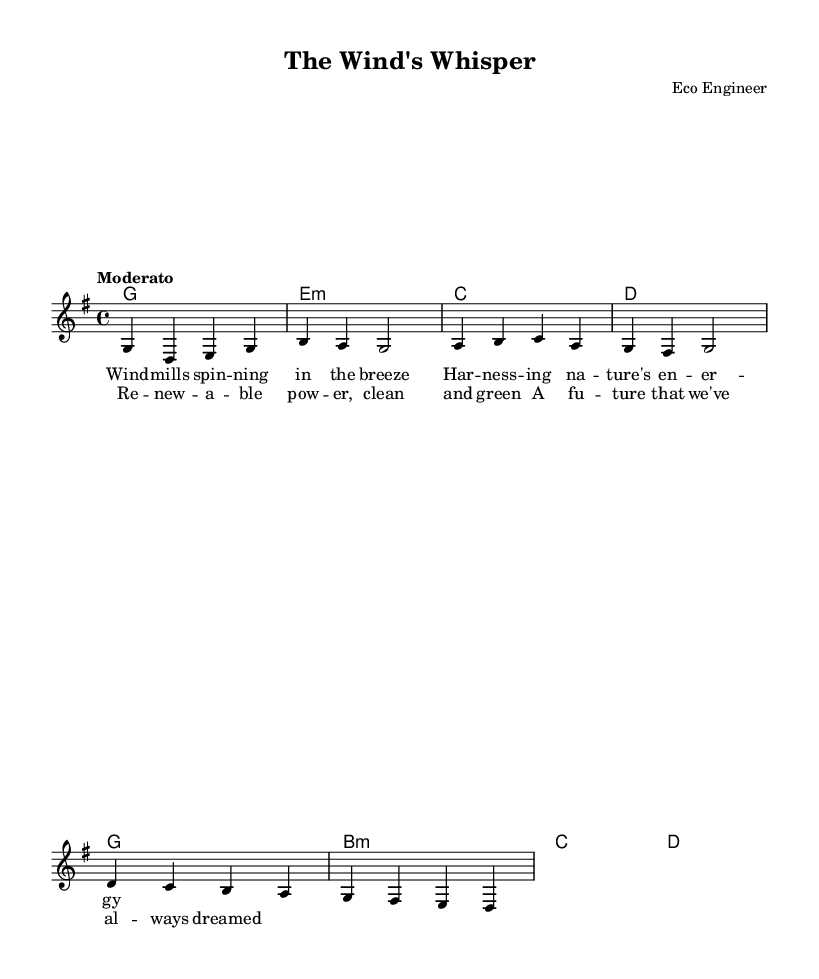What is the key signature of this music? The key signature is G major, which has one sharp (F#) indicated at the beginning of the staff.
Answer: G major What is the time signature of this music? The time signature is 4/4, which is shown at the beginning of the staff and indicates four beats per measure.
Answer: 4/4 What is the tempo marking for this piece? The tempo marking is "Moderato," indicating a moderate speed for the performance of the piece.
Answer: Moderato How many measures are in the melody section? The melody section consists of eight measures, which can be counted by looking at the notation and bar lines separating the sections.
Answer: Eight What is the first chord played in the harmonic progression? The first chord in the harmonic progression is G major, as indicated at the start of the chord names section.
Answer: G Which lyric appears in the chorus? The lyric "Renewable power, clean and green" appears in the chorus, as presented under the designated lyrics section for the chorus.
Answer: Renewable power, clean and green How many different chords are used in the song? The song uses four different chords: G, E minor, C, and D, as noted in the chord mode section.
Answer: Four 